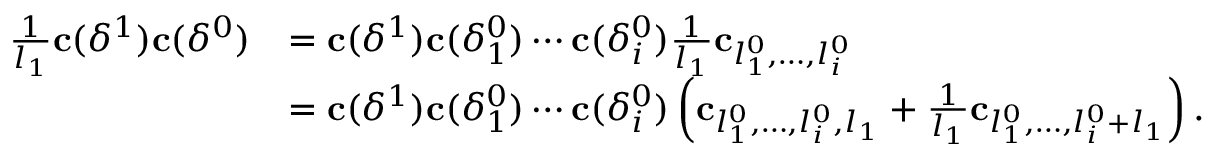<formula> <loc_0><loc_0><loc_500><loc_500>\begin{array} { r l } { \frac { 1 } { l _ { 1 } } c ( \delta ^ { 1 } ) c ( \delta ^ { 0 } ) } & { = c ( \delta ^ { 1 } ) c ( \delta _ { 1 } ^ { 0 } ) \cdots c ( \delta _ { i } ^ { 0 } ) \frac { 1 } { l _ { 1 } } c _ { l _ { 1 } ^ { 0 } , \dots , l _ { i } ^ { 0 } } } \\ & { = c ( \delta ^ { 1 } ) c ( \delta _ { 1 } ^ { 0 } ) \cdots c ( \delta _ { i } ^ { 0 } ) \left ( c _ { l _ { 1 } ^ { 0 } , \dots , l _ { i } ^ { 0 } , l _ { 1 } } + \frac { 1 } { l _ { 1 } } c _ { l _ { 1 } ^ { 0 } , \dots , l _ { i } ^ { 0 } + l _ { 1 } } \right ) . } \end{array}</formula> 